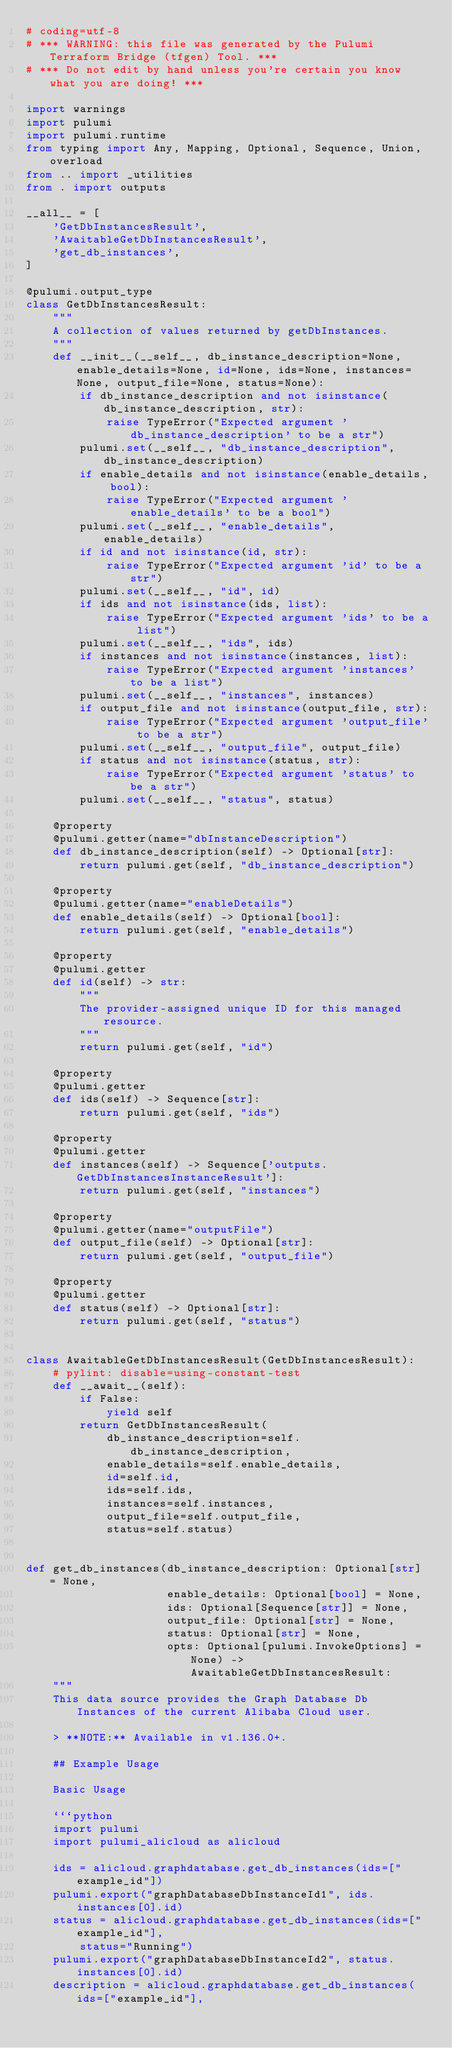Convert code to text. <code><loc_0><loc_0><loc_500><loc_500><_Python_># coding=utf-8
# *** WARNING: this file was generated by the Pulumi Terraform Bridge (tfgen) Tool. ***
# *** Do not edit by hand unless you're certain you know what you are doing! ***

import warnings
import pulumi
import pulumi.runtime
from typing import Any, Mapping, Optional, Sequence, Union, overload
from .. import _utilities
from . import outputs

__all__ = [
    'GetDbInstancesResult',
    'AwaitableGetDbInstancesResult',
    'get_db_instances',
]

@pulumi.output_type
class GetDbInstancesResult:
    """
    A collection of values returned by getDbInstances.
    """
    def __init__(__self__, db_instance_description=None, enable_details=None, id=None, ids=None, instances=None, output_file=None, status=None):
        if db_instance_description and not isinstance(db_instance_description, str):
            raise TypeError("Expected argument 'db_instance_description' to be a str")
        pulumi.set(__self__, "db_instance_description", db_instance_description)
        if enable_details and not isinstance(enable_details, bool):
            raise TypeError("Expected argument 'enable_details' to be a bool")
        pulumi.set(__self__, "enable_details", enable_details)
        if id and not isinstance(id, str):
            raise TypeError("Expected argument 'id' to be a str")
        pulumi.set(__self__, "id", id)
        if ids and not isinstance(ids, list):
            raise TypeError("Expected argument 'ids' to be a list")
        pulumi.set(__self__, "ids", ids)
        if instances and not isinstance(instances, list):
            raise TypeError("Expected argument 'instances' to be a list")
        pulumi.set(__self__, "instances", instances)
        if output_file and not isinstance(output_file, str):
            raise TypeError("Expected argument 'output_file' to be a str")
        pulumi.set(__self__, "output_file", output_file)
        if status and not isinstance(status, str):
            raise TypeError("Expected argument 'status' to be a str")
        pulumi.set(__self__, "status", status)

    @property
    @pulumi.getter(name="dbInstanceDescription")
    def db_instance_description(self) -> Optional[str]:
        return pulumi.get(self, "db_instance_description")

    @property
    @pulumi.getter(name="enableDetails")
    def enable_details(self) -> Optional[bool]:
        return pulumi.get(self, "enable_details")

    @property
    @pulumi.getter
    def id(self) -> str:
        """
        The provider-assigned unique ID for this managed resource.
        """
        return pulumi.get(self, "id")

    @property
    @pulumi.getter
    def ids(self) -> Sequence[str]:
        return pulumi.get(self, "ids")

    @property
    @pulumi.getter
    def instances(self) -> Sequence['outputs.GetDbInstancesInstanceResult']:
        return pulumi.get(self, "instances")

    @property
    @pulumi.getter(name="outputFile")
    def output_file(self) -> Optional[str]:
        return pulumi.get(self, "output_file")

    @property
    @pulumi.getter
    def status(self) -> Optional[str]:
        return pulumi.get(self, "status")


class AwaitableGetDbInstancesResult(GetDbInstancesResult):
    # pylint: disable=using-constant-test
    def __await__(self):
        if False:
            yield self
        return GetDbInstancesResult(
            db_instance_description=self.db_instance_description,
            enable_details=self.enable_details,
            id=self.id,
            ids=self.ids,
            instances=self.instances,
            output_file=self.output_file,
            status=self.status)


def get_db_instances(db_instance_description: Optional[str] = None,
                     enable_details: Optional[bool] = None,
                     ids: Optional[Sequence[str]] = None,
                     output_file: Optional[str] = None,
                     status: Optional[str] = None,
                     opts: Optional[pulumi.InvokeOptions] = None) -> AwaitableGetDbInstancesResult:
    """
    This data source provides the Graph Database Db Instances of the current Alibaba Cloud user.

    > **NOTE:** Available in v1.136.0+.

    ## Example Usage

    Basic Usage

    ```python
    import pulumi
    import pulumi_alicloud as alicloud

    ids = alicloud.graphdatabase.get_db_instances(ids=["example_id"])
    pulumi.export("graphDatabaseDbInstanceId1", ids.instances[0].id)
    status = alicloud.graphdatabase.get_db_instances(ids=["example_id"],
        status="Running")
    pulumi.export("graphDatabaseDbInstanceId2", status.instances[0].id)
    description = alicloud.graphdatabase.get_db_instances(ids=["example_id"],</code> 